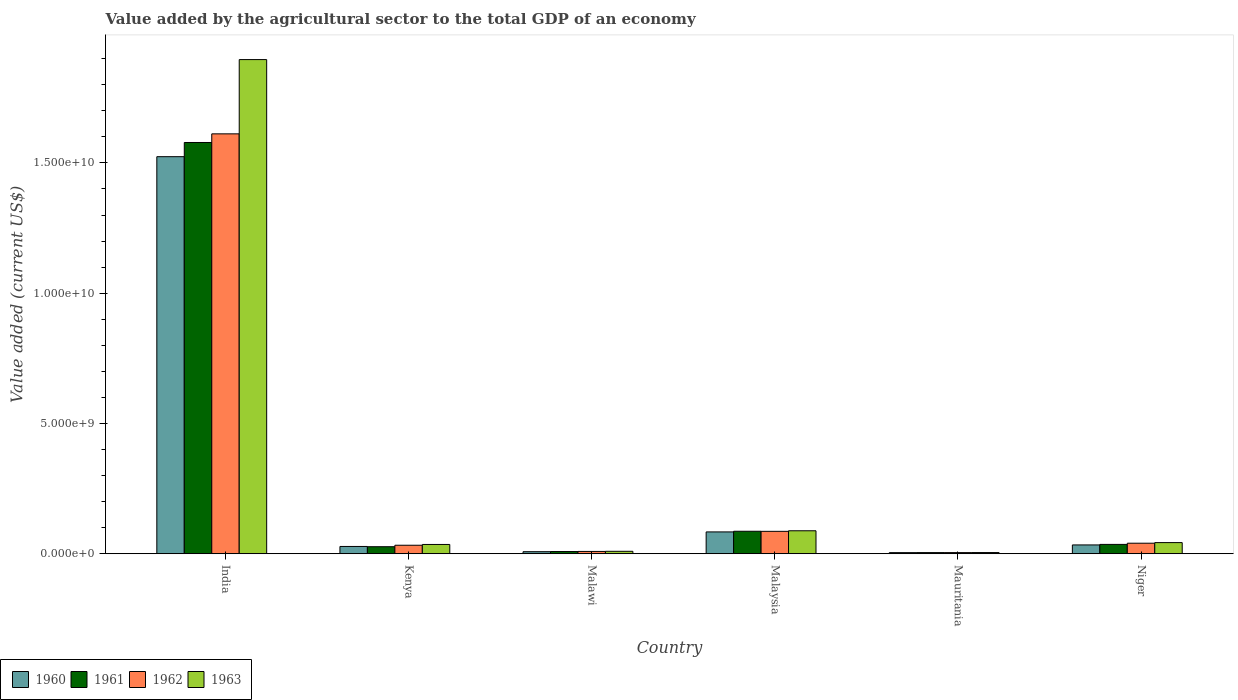Are the number of bars per tick equal to the number of legend labels?
Provide a short and direct response. Yes. How many bars are there on the 5th tick from the left?
Make the answer very short. 4. How many bars are there on the 1st tick from the right?
Make the answer very short. 4. What is the label of the 6th group of bars from the left?
Provide a short and direct response. Niger. In how many cases, is the number of bars for a given country not equal to the number of legend labels?
Provide a succinct answer. 0. What is the value added by the agricultural sector to the total GDP in 1963 in India?
Your answer should be very brief. 1.90e+1. Across all countries, what is the maximum value added by the agricultural sector to the total GDP in 1961?
Your response must be concise. 1.58e+1. Across all countries, what is the minimum value added by the agricultural sector to the total GDP in 1963?
Provide a short and direct response. 4.57e+07. In which country was the value added by the agricultural sector to the total GDP in 1961 minimum?
Keep it short and to the point. Mauritania. What is the total value added by the agricultural sector to the total GDP in 1961 in the graph?
Make the answer very short. 1.74e+1. What is the difference between the value added by the agricultural sector to the total GDP in 1962 in Malawi and that in Malaysia?
Offer a very short reply. -7.71e+08. What is the difference between the value added by the agricultural sector to the total GDP in 1963 in Malawi and the value added by the agricultural sector to the total GDP in 1960 in Malaysia?
Keep it short and to the point. -7.44e+08. What is the average value added by the agricultural sector to the total GDP in 1962 per country?
Your answer should be very brief. 2.97e+09. What is the difference between the value added by the agricultural sector to the total GDP of/in 1960 and value added by the agricultural sector to the total GDP of/in 1962 in Niger?
Provide a short and direct response. -6.55e+07. In how many countries, is the value added by the agricultural sector to the total GDP in 1963 greater than 8000000000 US$?
Offer a terse response. 1. What is the ratio of the value added by the agricultural sector to the total GDP in 1961 in Malaysia to that in Mauritania?
Make the answer very short. 19.73. Is the difference between the value added by the agricultural sector to the total GDP in 1960 in Kenya and Mauritania greater than the difference between the value added by the agricultural sector to the total GDP in 1962 in Kenya and Mauritania?
Provide a succinct answer. No. What is the difference between the highest and the second highest value added by the agricultural sector to the total GDP in 1961?
Your response must be concise. 1.49e+1. What is the difference between the highest and the lowest value added by the agricultural sector to the total GDP in 1962?
Keep it short and to the point. 1.61e+1. Is the sum of the value added by the agricultural sector to the total GDP in 1962 in Kenya and Mauritania greater than the maximum value added by the agricultural sector to the total GDP in 1961 across all countries?
Keep it short and to the point. No. What does the 1st bar from the left in Malawi represents?
Offer a terse response. 1960. Is it the case that in every country, the sum of the value added by the agricultural sector to the total GDP in 1960 and value added by the agricultural sector to the total GDP in 1963 is greater than the value added by the agricultural sector to the total GDP in 1962?
Ensure brevity in your answer.  Yes. How many bars are there?
Offer a terse response. 24. Are all the bars in the graph horizontal?
Make the answer very short. No. Does the graph contain any zero values?
Provide a succinct answer. No. Does the graph contain grids?
Offer a very short reply. No. Where does the legend appear in the graph?
Make the answer very short. Bottom left. How many legend labels are there?
Provide a short and direct response. 4. How are the legend labels stacked?
Your answer should be compact. Horizontal. What is the title of the graph?
Keep it short and to the point. Value added by the agricultural sector to the total GDP of an economy. What is the label or title of the X-axis?
Make the answer very short. Country. What is the label or title of the Y-axis?
Keep it short and to the point. Value added (current US$). What is the Value added (current US$) in 1960 in India?
Your answer should be compact. 1.52e+1. What is the Value added (current US$) in 1961 in India?
Offer a very short reply. 1.58e+1. What is the Value added (current US$) in 1962 in India?
Make the answer very short. 1.61e+1. What is the Value added (current US$) in 1963 in India?
Your response must be concise. 1.90e+1. What is the Value added (current US$) of 1960 in Kenya?
Provide a succinct answer. 2.80e+08. What is the Value added (current US$) of 1961 in Kenya?
Your answer should be compact. 2.70e+08. What is the Value added (current US$) in 1962 in Kenya?
Provide a succinct answer. 3.26e+08. What is the Value added (current US$) of 1963 in Kenya?
Ensure brevity in your answer.  3.56e+08. What is the Value added (current US$) in 1960 in Malawi?
Give a very brief answer. 7.88e+07. What is the Value added (current US$) in 1961 in Malawi?
Keep it short and to the point. 8.48e+07. What is the Value added (current US$) in 1962 in Malawi?
Your response must be concise. 8.90e+07. What is the Value added (current US$) of 1963 in Malawi?
Provide a short and direct response. 9.39e+07. What is the Value added (current US$) in 1960 in Malaysia?
Offer a very short reply. 8.38e+08. What is the Value added (current US$) in 1961 in Malaysia?
Offer a very short reply. 8.63e+08. What is the Value added (current US$) of 1962 in Malaysia?
Provide a succinct answer. 8.60e+08. What is the Value added (current US$) in 1963 in Malaysia?
Make the answer very short. 8.82e+08. What is the Value added (current US$) of 1960 in Mauritania?
Keep it short and to the point. 4.26e+07. What is the Value added (current US$) in 1961 in Mauritania?
Your response must be concise. 4.37e+07. What is the Value added (current US$) in 1962 in Mauritania?
Give a very brief answer. 4.41e+07. What is the Value added (current US$) in 1963 in Mauritania?
Give a very brief answer. 4.57e+07. What is the Value added (current US$) in 1960 in Niger?
Give a very brief answer. 3.39e+08. What is the Value added (current US$) in 1961 in Niger?
Your response must be concise. 3.59e+08. What is the Value added (current US$) of 1962 in Niger?
Ensure brevity in your answer.  4.04e+08. What is the Value added (current US$) of 1963 in Niger?
Give a very brief answer. 4.28e+08. Across all countries, what is the maximum Value added (current US$) of 1960?
Offer a very short reply. 1.52e+1. Across all countries, what is the maximum Value added (current US$) of 1961?
Keep it short and to the point. 1.58e+1. Across all countries, what is the maximum Value added (current US$) in 1962?
Keep it short and to the point. 1.61e+1. Across all countries, what is the maximum Value added (current US$) in 1963?
Make the answer very short. 1.90e+1. Across all countries, what is the minimum Value added (current US$) in 1960?
Offer a very short reply. 4.26e+07. Across all countries, what is the minimum Value added (current US$) in 1961?
Provide a succinct answer. 4.37e+07. Across all countries, what is the minimum Value added (current US$) in 1962?
Keep it short and to the point. 4.41e+07. Across all countries, what is the minimum Value added (current US$) in 1963?
Ensure brevity in your answer.  4.57e+07. What is the total Value added (current US$) in 1960 in the graph?
Your answer should be compact. 1.68e+1. What is the total Value added (current US$) in 1961 in the graph?
Give a very brief answer. 1.74e+1. What is the total Value added (current US$) in 1962 in the graph?
Give a very brief answer. 1.78e+1. What is the total Value added (current US$) in 1963 in the graph?
Offer a very short reply. 2.08e+1. What is the difference between the Value added (current US$) of 1960 in India and that in Kenya?
Your answer should be very brief. 1.50e+1. What is the difference between the Value added (current US$) in 1961 in India and that in Kenya?
Keep it short and to the point. 1.55e+1. What is the difference between the Value added (current US$) in 1962 in India and that in Kenya?
Provide a succinct answer. 1.58e+1. What is the difference between the Value added (current US$) of 1963 in India and that in Kenya?
Ensure brevity in your answer.  1.86e+1. What is the difference between the Value added (current US$) of 1960 in India and that in Malawi?
Keep it short and to the point. 1.52e+1. What is the difference between the Value added (current US$) in 1961 in India and that in Malawi?
Your answer should be very brief. 1.57e+1. What is the difference between the Value added (current US$) of 1962 in India and that in Malawi?
Keep it short and to the point. 1.60e+1. What is the difference between the Value added (current US$) in 1963 in India and that in Malawi?
Provide a short and direct response. 1.89e+1. What is the difference between the Value added (current US$) in 1960 in India and that in Malaysia?
Make the answer very short. 1.44e+1. What is the difference between the Value added (current US$) of 1961 in India and that in Malaysia?
Your response must be concise. 1.49e+1. What is the difference between the Value added (current US$) of 1962 in India and that in Malaysia?
Offer a very short reply. 1.53e+1. What is the difference between the Value added (current US$) of 1963 in India and that in Malaysia?
Offer a terse response. 1.81e+1. What is the difference between the Value added (current US$) in 1960 in India and that in Mauritania?
Ensure brevity in your answer.  1.52e+1. What is the difference between the Value added (current US$) of 1961 in India and that in Mauritania?
Provide a succinct answer. 1.57e+1. What is the difference between the Value added (current US$) of 1962 in India and that in Mauritania?
Give a very brief answer. 1.61e+1. What is the difference between the Value added (current US$) of 1963 in India and that in Mauritania?
Give a very brief answer. 1.89e+1. What is the difference between the Value added (current US$) of 1960 in India and that in Niger?
Provide a succinct answer. 1.49e+1. What is the difference between the Value added (current US$) in 1961 in India and that in Niger?
Your answer should be very brief. 1.54e+1. What is the difference between the Value added (current US$) in 1962 in India and that in Niger?
Your response must be concise. 1.57e+1. What is the difference between the Value added (current US$) of 1963 in India and that in Niger?
Your answer should be compact. 1.85e+1. What is the difference between the Value added (current US$) in 1960 in Kenya and that in Malawi?
Offer a very short reply. 2.01e+08. What is the difference between the Value added (current US$) in 1961 in Kenya and that in Malawi?
Keep it short and to the point. 1.85e+08. What is the difference between the Value added (current US$) of 1962 in Kenya and that in Malawi?
Your response must be concise. 2.37e+08. What is the difference between the Value added (current US$) in 1963 in Kenya and that in Malawi?
Provide a short and direct response. 2.62e+08. What is the difference between the Value added (current US$) of 1960 in Kenya and that in Malaysia?
Your answer should be compact. -5.58e+08. What is the difference between the Value added (current US$) of 1961 in Kenya and that in Malaysia?
Your answer should be very brief. -5.93e+08. What is the difference between the Value added (current US$) of 1962 in Kenya and that in Malaysia?
Give a very brief answer. -5.34e+08. What is the difference between the Value added (current US$) in 1963 in Kenya and that in Malaysia?
Keep it short and to the point. -5.25e+08. What is the difference between the Value added (current US$) of 1960 in Kenya and that in Mauritania?
Your response must be concise. 2.37e+08. What is the difference between the Value added (current US$) of 1961 in Kenya and that in Mauritania?
Offer a very short reply. 2.26e+08. What is the difference between the Value added (current US$) in 1962 in Kenya and that in Mauritania?
Provide a succinct answer. 2.82e+08. What is the difference between the Value added (current US$) in 1963 in Kenya and that in Mauritania?
Offer a very short reply. 3.11e+08. What is the difference between the Value added (current US$) of 1960 in Kenya and that in Niger?
Give a very brief answer. -5.89e+07. What is the difference between the Value added (current US$) in 1961 in Kenya and that in Niger?
Offer a very short reply. -8.87e+07. What is the difference between the Value added (current US$) of 1962 in Kenya and that in Niger?
Your answer should be compact. -7.79e+07. What is the difference between the Value added (current US$) in 1963 in Kenya and that in Niger?
Make the answer very short. -7.14e+07. What is the difference between the Value added (current US$) of 1960 in Malawi and that in Malaysia?
Offer a terse response. -7.59e+08. What is the difference between the Value added (current US$) of 1961 in Malawi and that in Malaysia?
Keep it short and to the point. -7.78e+08. What is the difference between the Value added (current US$) of 1962 in Malawi and that in Malaysia?
Give a very brief answer. -7.71e+08. What is the difference between the Value added (current US$) of 1963 in Malawi and that in Malaysia?
Provide a short and direct response. -7.88e+08. What is the difference between the Value added (current US$) of 1960 in Malawi and that in Mauritania?
Provide a short and direct response. 3.62e+07. What is the difference between the Value added (current US$) of 1961 in Malawi and that in Mauritania?
Make the answer very short. 4.11e+07. What is the difference between the Value added (current US$) of 1962 in Malawi and that in Mauritania?
Give a very brief answer. 4.49e+07. What is the difference between the Value added (current US$) in 1963 in Malawi and that in Mauritania?
Provide a short and direct response. 4.83e+07. What is the difference between the Value added (current US$) of 1960 in Malawi and that in Niger?
Your answer should be compact. -2.60e+08. What is the difference between the Value added (current US$) in 1961 in Malawi and that in Niger?
Keep it short and to the point. -2.74e+08. What is the difference between the Value added (current US$) of 1962 in Malawi and that in Niger?
Provide a short and direct response. -3.15e+08. What is the difference between the Value added (current US$) of 1963 in Malawi and that in Niger?
Give a very brief answer. -3.34e+08. What is the difference between the Value added (current US$) in 1960 in Malaysia and that in Mauritania?
Ensure brevity in your answer.  7.95e+08. What is the difference between the Value added (current US$) of 1961 in Malaysia and that in Mauritania?
Provide a succinct answer. 8.19e+08. What is the difference between the Value added (current US$) of 1962 in Malaysia and that in Mauritania?
Make the answer very short. 8.16e+08. What is the difference between the Value added (current US$) in 1963 in Malaysia and that in Mauritania?
Your response must be concise. 8.36e+08. What is the difference between the Value added (current US$) of 1960 in Malaysia and that in Niger?
Provide a short and direct response. 4.99e+08. What is the difference between the Value added (current US$) of 1961 in Malaysia and that in Niger?
Give a very brief answer. 5.04e+08. What is the difference between the Value added (current US$) in 1962 in Malaysia and that in Niger?
Offer a very short reply. 4.56e+08. What is the difference between the Value added (current US$) of 1963 in Malaysia and that in Niger?
Provide a short and direct response. 4.54e+08. What is the difference between the Value added (current US$) of 1960 in Mauritania and that in Niger?
Your answer should be very brief. -2.96e+08. What is the difference between the Value added (current US$) of 1961 in Mauritania and that in Niger?
Offer a terse response. -3.15e+08. What is the difference between the Value added (current US$) of 1962 in Mauritania and that in Niger?
Your response must be concise. -3.60e+08. What is the difference between the Value added (current US$) in 1963 in Mauritania and that in Niger?
Offer a very short reply. -3.82e+08. What is the difference between the Value added (current US$) of 1960 in India and the Value added (current US$) of 1961 in Kenya?
Your answer should be very brief. 1.50e+1. What is the difference between the Value added (current US$) in 1960 in India and the Value added (current US$) in 1962 in Kenya?
Make the answer very short. 1.49e+1. What is the difference between the Value added (current US$) of 1960 in India and the Value added (current US$) of 1963 in Kenya?
Your answer should be very brief. 1.49e+1. What is the difference between the Value added (current US$) of 1961 in India and the Value added (current US$) of 1962 in Kenya?
Make the answer very short. 1.55e+1. What is the difference between the Value added (current US$) in 1961 in India and the Value added (current US$) in 1963 in Kenya?
Ensure brevity in your answer.  1.54e+1. What is the difference between the Value added (current US$) in 1962 in India and the Value added (current US$) in 1963 in Kenya?
Your response must be concise. 1.58e+1. What is the difference between the Value added (current US$) of 1960 in India and the Value added (current US$) of 1961 in Malawi?
Ensure brevity in your answer.  1.52e+1. What is the difference between the Value added (current US$) in 1960 in India and the Value added (current US$) in 1962 in Malawi?
Keep it short and to the point. 1.51e+1. What is the difference between the Value added (current US$) of 1960 in India and the Value added (current US$) of 1963 in Malawi?
Your response must be concise. 1.51e+1. What is the difference between the Value added (current US$) of 1961 in India and the Value added (current US$) of 1962 in Malawi?
Provide a short and direct response. 1.57e+1. What is the difference between the Value added (current US$) in 1961 in India and the Value added (current US$) in 1963 in Malawi?
Provide a short and direct response. 1.57e+1. What is the difference between the Value added (current US$) of 1962 in India and the Value added (current US$) of 1963 in Malawi?
Keep it short and to the point. 1.60e+1. What is the difference between the Value added (current US$) of 1960 in India and the Value added (current US$) of 1961 in Malaysia?
Provide a short and direct response. 1.44e+1. What is the difference between the Value added (current US$) in 1960 in India and the Value added (current US$) in 1962 in Malaysia?
Your answer should be compact. 1.44e+1. What is the difference between the Value added (current US$) of 1960 in India and the Value added (current US$) of 1963 in Malaysia?
Give a very brief answer. 1.44e+1. What is the difference between the Value added (current US$) in 1961 in India and the Value added (current US$) in 1962 in Malaysia?
Offer a very short reply. 1.49e+1. What is the difference between the Value added (current US$) of 1961 in India and the Value added (current US$) of 1963 in Malaysia?
Give a very brief answer. 1.49e+1. What is the difference between the Value added (current US$) in 1962 in India and the Value added (current US$) in 1963 in Malaysia?
Your response must be concise. 1.52e+1. What is the difference between the Value added (current US$) of 1960 in India and the Value added (current US$) of 1961 in Mauritania?
Make the answer very short. 1.52e+1. What is the difference between the Value added (current US$) of 1960 in India and the Value added (current US$) of 1962 in Mauritania?
Make the answer very short. 1.52e+1. What is the difference between the Value added (current US$) in 1960 in India and the Value added (current US$) in 1963 in Mauritania?
Provide a short and direct response. 1.52e+1. What is the difference between the Value added (current US$) in 1961 in India and the Value added (current US$) in 1962 in Mauritania?
Your answer should be very brief. 1.57e+1. What is the difference between the Value added (current US$) of 1961 in India and the Value added (current US$) of 1963 in Mauritania?
Offer a very short reply. 1.57e+1. What is the difference between the Value added (current US$) of 1962 in India and the Value added (current US$) of 1963 in Mauritania?
Your answer should be compact. 1.61e+1. What is the difference between the Value added (current US$) of 1960 in India and the Value added (current US$) of 1961 in Niger?
Provide a succinct answer. 1.49e+1. What is the difference between the Value added (current US$) in 1960 in India and the Value added (current US$) in 1962 in Niger?
Your response must be concise. 1.48e+1. What is the difference between the Value added (current US$) in 1960 in India and the Value added (current US$) in 1963 in Niger?
Make the answer very short. 1.48e+1. What is the difference between the Value added (current US$) in 1961 in India and the Value added (current US$) in 1962 in Niger?
Make the answer very short. 1.54e+1. What is the difference between the Value added (current US$) in 1961 in India and the Value added (current US$) in 1963 in Niger?
Offer a very short reply. 1.54e+1. What is the difference between the Value added (current US$) of 1962 in India and the Value added (current US$) of 1963 in Niger?
Make the answer very short. 1.57e+1. What is the difference between the Value added (current US$) of 1960 in Kenya and the Value added (current US$) of 1961 in Malawi?
Keep it short and to the point. 1.95e+08. What is the difference between the Value added (current US$) in 1960 in Kenya and the Value added (current US$) in 1962 in Malawi?
Your answer should be compact. 1.91e+08. What is the difference between the Value added (current US$) in 1960 in Kenya and the Value added (current US$) in 1963 in Malawi?
Provide a succinct answer. 1.86e+08. What is the difference between the Value added (current US$) in 1961 in Kenya and the Value added (current US$) in 1962 in Malawi?
Make the answer very short. 1.81e+08. What is the difference between the Value added (current US$) in 1961 in Kenya and the Value added (current US$) in 1963 in Malawi?
Offer a very short reply. 1.76e+08. What is the difference between the Value added (current US$) of 1962 in Kenya and the Value added (current US$) of 1963 in Malawi?
Give a very brief answer. 2.32e+08. What is the difference between the Value added (current US$) in 1960 in Kenya and the Value added (current US$) in 1961 in Malaysia?
Your answer should be compact. -5.83e+08. What is the difference between the Value added (current US$) in 1960 in Kenya and the Value added (current US$) in 1962 in Malaysia?
Your answer should be compact. -5.80e+08. What is the difference between the Value added (current US$) in 1960 in Kenya and the Value added (current US$) in 1963 in Malaysia?
Your answer should be very brief. -6.02e+08. What is the difference between the Value added (current US$) of 1961 in Kenya and the Value added (current US$) of 1962 in Malaysia?
Make the answer very short. -5.90e+08. What is the difference between the Value added (current US$) of 1961 in Kenya and the Value added (current US$) of 1963 in Malaysia?
Give a very brief answer. -6.11e+08. What is the difference between the Value added (current US$) in 1962 in Kenya and the Value added (current US$) in 1963 in Malaysia?
Keep it short and to the point. -5.55e+08. What is the difference between the Value added (current US$) of 1960 in Kenya and the Value added (current US$) of 1961 in Mauritania?
Ensure brevity in your answer.  2.36e+08. What is the difference between the Value added (current US$) in 1960 in Kenya and the Value added (current US$) in 1962 in Mauritania?
Ensure brevity in your answer.  2.36e+08. What is the difference between the Value added (current US$) in 1960 in Kenya and the Value added (current US$) in 1963 in Mauritania?
Provide a succinct answer. 2.34e+08. What is the difference between the Value added (current US$) of 1961 in Kenya and the Value added (current US$) of 1962 in Mauritania?
Make the answer very short. 2.26e+08. What is the difference between the Value added (current US$) in 1961 in Kenya and the Value added (current US$) in 1963 in Mauritania?
Make the answer very short. 2.25e+08. What is the difference between the Value added (current US$) of 1962 in Kenya and the Value added (current US$) of 1963 in Mauritania?
Your answer should be compact. 2.81e+08. What is the difference between the Value added (current US$) in 1960 in Kenya and the Value added (current US$) in 1961 in Niger?
Provide a short and direct response. -7.92e+07. What is the difference between the Value added (current US$) of 1960 in Kenya and the Value added (current US$) of 1962 in Niger?
Offer a very short reply. -1.24e+08. What is the difference between the Value added (current US$) of 1960 in Kenya and the Value added (current US$) of 1963 in Niger?
Offer a very short reply. -1.48e+08. What is the difference between the Value added (current US$) of 1961 in Kenya and the Value added (current US$) of 1962 in Niger?
Offer a terse response. -1.34e+08. What is the difference between the Value added (current US$) of 1961 in Kenya and the Value added (current US$) of 1963 in Niger?
Provide a succinct answer. -1.58e+08. What is the difference between the Value added (current US$) in 1962 in Kenya and the Value added (current US$) in 1963 in Niger?
Your answer should be compact. -1.02e+08. What is the difference between the Value added (current US$) of 1960 in Malawi and the Value added (current US$) of 1961 in Malaysia?
Your answer should be very brief. -7.84e+08. What is the difference between the Value added (current US$) in 1960 in Malawi and the Value added (current US$) in 1962 in Malaysia?
Give a very brief answer. -7.81e+08. What is the difference between the Value added (current US$) of 1960 in Malawi and the Value added (current US$) of 1963 in Malaysia?
Your answer should be compact. -8.03e+08. What is the difference between the Value added (current US$) of 1961 in Malawi and the Value added (current US$) of 1962 in Malaysia?
Offer a very short reply. -7.75e+08. What is the difference between the Value added (current US$) of 1961 in Malawi and the Value added (current US$) of 1963 in Malaysia?
Ensure brevity in your answer.  -7.97e+08. What is the difference between the Value added (current US$) of 1962 in Malawi and the Value added (current US$) of 1963 in Malaysia?
Your answer should be very brief. -7.93e+08. What is the difference between the Value added (current US$) in 1960 in Malawi and the Value added (current US$) in 1961 in Mauritania?
Your response must be concise. 3.51e+07. What is the difference between the Value added (current US$) of 1960 in Malawi and the Value added (current US$) of 1962 in Mauritania?
Keep it short and to the point. 3.47e+07. What is the difference between the Value added (current US$) in 1960 in Malawi and the Value added (current US$) in 1963 in Mauritania?
Give a very brief answer. 3.32e+07. What is the difference between the Value added (current US$) in 1961 in Malawi and the Value added (current US$) in 1962 in Mauritania?
Your answer should be compact. 4.07e+07. What is the difference between the Value added (current US$) of 1961 in Malawi and the Value added (current US$) of 1963 in Mauritania?
Make the answer very short. 3.92e+07. What is the difference between the Value added (current US$) in 1962 in Malawi and the Value added (current US$) in 1963 in Mauritania?
Your response must be concise. 4.34e+07. What is the difference between the Value added (current US$) of 1960 in Malawi and the Value added (current US$) of 1961 in Niger?
Make the answer very short. -2.80e+08. What is the difference between the Value added (current US$) in 1960 in Malawi and the Value added (current US$) in 1962 in Niger?
Ensure brevity in your answer.  -3.25e+08. What is the difference between the Value added (current US$) in 1960 in Malawi and the Value added (current US$) in 1963 in Niger?
Offer a terse response. -3.49e+08. What is the difference between the Value added (current US$) of 1961 in Malawi and the Value added (current US$) of 1962 in Niger?
Give a very brief answer. -3.19e+08. What is the difference between the Value added (current US$) in 1961 in Malawi and the Value added (current US$) in 1963 in Niger?
Offer a terse response. -3.43e+08. What is the difference between the Value added (current US$) in 1962 in Malawi and the Value added (current US$) in 1963 in Niger?
Your response must be concise. -3.39e+08. What is the difference between the Value added (current US$) of 1960 in Malaysia and the Value added (current US$) of 1961 in Mauritania?
Provide a succinct answer. 7.94e+08. What is the difference between the Value added (current US$) in 1960 in Malaysia and the Value added (current US$) in 1962 in Mauritania?
Your answer should be compact. 7.94e+08. What is the difference between the Value added (current US$) of 1960 in Malaysia and the Value added (current US$) of 1963 in Mauritania?
Your response must be concise. 7.92e+08. What is the difference between the Value added (current US$) in 1961 in Malaysia and the Value added (current US$) in 1962 in Mauritania?
Provide a succinct answer. 8.19e+08. What is the difference between the Value added (current US$) in 1961 in Malaysia and the Value added (current US$) in 1963 in Mauritania?
Offer a very short reply. 8.17e+08. What is the difference between the Value added (current US$) of 1962 in Malaysia and the Value added (current US$) of 1963 in Mauritania?
Offer a terse response. 8.14e+08. What is the difference between the Value added (current US$) in 1960 in Malaysia and the Value added (current US$) in 1961 in Niger?
Give a very brief answer. 4.79e+08. What is the difference between the Value added (current US$) in 1960 in Malaysia and the Value added (current US$) in 1962 in Niger?
Make the answer very short. 4.34e+08. What is the difference between the Value added (current US$) in 1960 in Malaysia and the Value added (current US$) in 1963 in Niger?
Your answer should be compact. 4.10e+08. What is the difference between the Value added (current US$) in 1961 in Malaysia and the Value added (current US$) in 1962 in Niger?
Your response must be concise. 4.59e+08. What is the difference between the Value added (current US$) of 1961 in Malaysia and the Value added (current US$) of 1963 in Niger?
Keep it short and to the point. 4.35e+08. What is the difference between the Value added (current US$) of 1962 in Malaysia and the Value added (current US$) of 1963 in Niger?
Provide a succinct answer. 4.32e+08. What is the difference between the Value added (current US$) of 1960 in Mauritania and the Value added (current US$) of 1961 in Niger?
Offer a terse response. -3.16e+08. What is the difference between the Value added (current US$) of 1960 in Mauritania and the Value added (current US$) of 1962 in Niger?
Your answer should be very brief. -3.62e+08. What is the difference between the Value added (current US$) in 1960 in Mauritania and the Value added (current US$) in 1963 in Niger?
Your response must be concise. -3.85e+08. What is the difference between the Value added (current US$) of 1961 in Mauritania and the Value added (current US$) of 1962 in Niger?
Ensure brevity in your answer.  -3.60e+08. What is the difference between the Value added (current US$) of 1961 in Mauritania and the Value added (current US$) of 1963 in Niger?
Keep it short and to the point. -3.84e+08. What is the difference between the Value added (current US$) of 1962 in Mauritania and the Value added (current US$) of 1963 in Niger?
Ensure brevity in your answer.  -3.84e+08. What is the average Value added (current US$) in 1960 per country?
Offer a terse response. 2.80e+09. What is the average Value added (current US$) in 1961 per country?
Your answer should be very brief. 2.90e+09. What is the average Value added (current US$) of 1962 per country?
Offer a terse response. 2.97e+09. What is the average Value added (current US$) of 1963 per country?
Ensure brevity in your answer.  3.46e+09. What is the difference between the Value added (current US$) of 1960 and Value added (current US$) of 1961 in India?
Your answer should be compact. -5.45e+08. What is the difference between the Value added (current US$) in 1960 and Value added (current US$) in 1962 in India?
Your response must be concise. -8.76e+08. What is the difference between the Value added (current US$) of 1960 and Value added (current US$) of 1963 in India?
Your response must be concise. -3.73e+09. What is the difference between the Value added (current US$) of 1961 and Value added (current US$) of 1962 in India?
Give a very brief answer. -3.32e+08. What is the difference between the Value added (current US$) of 1961 and Value added (current US$) of 1963 in India?
Give a very brief answer. -3.18e+09. What is the difference between the Value added (current US$) of 1962 and Value added (current US$) of 1963 in India?
Give a very brief answer. -2.85e+09. What is the difference between the Value added (current US$) in 1960 and Value added (current US$) in 1961 in Kenya?
Your response must be concise. 9.51e+06. What is the difference between the Value added (current US$) in 1960 and Value added (current US$) in 1962 in Kenya?
Keep it short and to the point. -4.65e+07. What is the difference between the Value added (current US$) in 1960 and Value added (current US$) in 1963 in Kenya?
Provide a short and direct response. -7.66e+07. What is the difference between the Value added (current US$) of 1961 and Value added (current US$) of 1962 in Kenya?
Your answer should be compact. -5.60e+07. What is the difference between the Value added (current US$) in 1961 and Value added (current US$) in 1963 in Kenya?
Offer a terse response. -8.61e+07. What is the difference between the Value added (current US$) of 1962 and Value added (current US$) of 1963 in Kenya?
Offer a terse response. -3.01e+07. What is the difference between the Value added (current US$) of 1960 and Value added (current US$) of 1961 in Malawi?
Offer a terse response. -6.02e+06. What is the difference between the Value added (current US$) of 1960 and Value added (current US$) of 1962 in Malawi?
Ensure brevity in your answer.  -1.02e+07. What is the difference between the Value added (current US$) of 1960 and Value added (current US$) of 1963 in Malawi?
Your response must be concise. -1.51e+07. What is the difference between the Value added (current US$) of 1961 and Value added (current US$) of 1962 in Malawi?
Ensure brevity in your answer.  -4.20e+06. What is the difference between the Value added (current US$) in 1961 and Value added (current US$) in 1963 in Malawi?
Provide a succinct answer. -9.10e+06. What is the difference between the Value added (current US$) in 1962 and Value added (current US$) in 1963 in Malawi?
Your answer should be compact. -4.90e+06. What is the difference between the Value added (current US$) in 1960 and Value added (current US$) in 1961 in Malaysia?
Make the answer very short. -2.54e+07. What is the difference between the Value added (current US$) of 1960 and Value added (current US$) of 1962 in Malaysia?
Give a very brief answer. -2.23e+07. What is the difference between the Value added (current US$) in 1960 and Value added (current US$) in 1963 in Malaysia?
Ensure brevity in your answer.  -4.39e+07. What is the difference between the Value added (current US$) in 1961 and Value added (current US$) in 1962 in Malaysia?
Offer a terse response. 3.09e+06. What is the difference between the Value added (current US$) of 1961 and Value added (current US$) of 1963 in Malaysia?
Ensure brevity in your answer.  -1.85e+07. What is the difference between the Value added (current US$) of 1962 and Value added (current US$) of 1963 in Malaysia?
Offer a very short reply. -2.16e+07. What is the difference between the Value added (current US$) in 1960 and Value added (current US$) in 1961 in Mauritania?
Provide a succinct answer. -1.15e+06. What is the difference between the Value added (current US$) of 1960 and Value added (current US$) of 1962 in Mauritania?
Your response must be concise. -1.54e+06. What is the difference between the Value added (current US$) in 1960 and Value added (current US$) in 1963 in Mauritania?
Offer a very short reply. -3.07e+06. What is the difference between the Value added (current US$) in 1961 and Value added (current US$) in 1962 in Mauritania?
Offer a terse response. -3.84e+05. What is the difference between the Value added (current US$) in 1961 and Value added (current US$) in 1963 in Mauritania?
Keep it short and to the point. -1.92e+06. What is the difference between the Value added (current US$) of 1962 and Value added (current US$) of 1963 in Mauritania?
Give a very brief answer. -1.54e+06. What is the difference between the Value added (current US$) in 1960 and Value added (current US$) in 1961 in Niger?
Provide a short and direct response. -2.03e+07. What is the difference between the Value added (current US$) in 1960 and Value added (current US$) in 1962 in Niger?
Keep it short and to the point. -6.55e+07. What is the difference between the Value added (current US$) in 1960 and Value added (current US$) in 1963 in Niger?
Your answer should be very brief. -8.91e+07. What is the difference between the Value added (current US$) in 1961 and Value added (current US$) in 1962 in Niger?
Make the answer very short. -4.52e+07. What is the difference between the Value added (current US$) of 1961 and Value added (current US$) of 1963 in Niger?
Provide a short and direct response. -6.88e+07. What is the difference between the Value added (current US$) in 1962 and Value added (current US$) in 1963 in Niger?
Provide a short and direct response. -2.36e+07. What is the ratio of the Value added (current US$) in 1960 in India to that in Kenya?
Offer a very short reply. 54.48. What is the ratio of the Value added (current US$) in 1961 in India to that in Kenya?
Provide a succinct answer. 58.42. What is the ratio of the Value added (current US$) of 1962 in India to that in Kenya?
Give a very brief answer. 49.4. What is the ratio of the Value added (current US$) of 1963 in India to that in Kenya?
Offer a terse response. 53.23. What is the ratio of the Value added (current US$) in 1960 in India to that in Malawi?
Your response must be concise. 193.33. What is the ratio of the Value added (current US$) of 1961 in India to that in Malawi?
Make the answer very short. 186.04. What is the ratio of the Value added (current US$) of 1962 in India to that in Malawi?
Ensure brevity in your answer.  180.99. What is the ratio of the Value added (current US$) of 1963 in India to that in Malawi?
Keep it short and to the point. 201.89. What is the ratio of the Value added (current US$) in 1960 in India to that in Malaysia?
Your answer should be very brief. 18.19. What is the ratio of the Value added (current US$) in 1961 in India to that in Malaysia?
Keep it short and to the point. 18.29. What is the ratio of the Value added (current US$) of 1962 in India to that in Malaysia?
Make the answer very short. 18.74. What is the ratio of the Value added (current US$) of 1963 in India to that in Malaysia?
Make the answer very short. 21.51. What is the ratio of the Value added (current US$) in 1960 in India to that in Mauritania?
Provide a short and direct response. 357.73. What is the ratio of the Value added (current US$) of 1961 in India to that in Mauritania?
Your response must be concise. 360.77. What is the ratio of the Value added (current US$) of 1962 in India to that in Mauritania?
Offer a very short reply. 365.15. What is the ratio of the Value added (current US$) of 1963 in India to that in Mauritania?
Keep it short and to the point. 415.29. What is the ratio of the Value added (current US$) of 1960 in India to that in Niger?
Provide a succinct answer. 45. What is the ratio of the Value added (current US$) of 1961 in India to that in Niger?
Provide a short and direct response. 43.97. What is the ratio of the Value added (current US$) of 1962 in India to that in Niger?
Your answer should be very brief. 39.88. What is the ratio of the Value added (current US$) in 1963 in India to that in Niger?
Your response must be concise. 44.34. What is the ratio of the Value added (current US$) of 1960 in Kenya to that in Malawi?
Provide a short and direct response. 3.55. What is the ratio of the Value added (current US$) in 1961 in Kenya to that in Malawi?
Your response must be concise. 3.18. What is the ratio of the Value added (current US$) of 1962 in Kenya to that in Malawi?
Give a very brief answer. 3.66. What is the ratio of the Value added (current US$) in 1963 in Kenya to that in Malawi?
Provide a succinct answer. 3.79. What is the ratio of the Value added (current US$) in 1960 in Kenya to that in Malaysia?
Your answer should be very brief. 0.33. What is the ratio of the Value added (current US$) in 1961 in Kenya to that in Malaysia?
Your answer should be very brief. 0.31. What is the ratio of the Value added (current US$) in 1962 in Kenya to that in Malaysia?
Your answer should be compact. 0.38. What is the ratio of the Value added (current US$) in 1963 in Kenya to that in Malaysia?
Make the answer very short. 0.4. What is the ratio of the Value added (current US$) in 1960 in Kenya to that in Mauritania?
Your response must be concise. 6.57. What is the ratio of the Value added (current US$) in 1961 in Kenya to that in Mauritania?
Keep it short and to the point. 6.18. What is the ratio of the Value added (current US$) in 1962 in Kenya to that in Mauritania?
Your answer should be compact. 7.39. What is the ratio of the Value added (current US$) of 1963 in Kenya to that in Mauritania?
Your answer should be very brief. 7.8. What is the ratio of the Value added (current US$) of 1960 in Kenya to that in Niger?
Make the answer very short. 0.83. What is the ratio of the Value added (current US$) in 1961 in Kenya to that in Niger?
Your answer should be very brief. 0.75. What is the ratio of the Value added (current US$) of 1962 in Kenya to that in Niger?
Your answer should be very brief. 0.81. What is the ratio of the Value added (current US$) of 1963 in Kenya to that in Niger?
Offer a very short reply. 0.83. What is the ratio of the Value added (current US$) of 1960 in Malawi to that in Malaysia?
Give a very brief answer. 0.09. What is the ratio of the Value added (current US$) in 1961 in Malawi to that in Malaysia?
Provide a succinct answer. 0.1. What is the ratio of the Value added (current US$) of 1962 in Malawi to that in Malaysia?
Offer a very short reply. 0.1. What is the ratio of the Value added (current US$) in 1963 in Malawi to that in Malaysia?
Provide a succinct answer. 0.11. What is the ratio of the Value added (current US$) in 1960 in Malawi to that in Mauritania?
Provide a succinct answer. 1.85. What is the ratio of the Value added (current US$) in 1961 in Malawi to that in Mauritania?
Provide a short and direct response. 1.94. What is the ratio of the Value added (current US$) in 1962 in Malawi to that in Mauritania?
Give a very brief answer. 2.02. What is the ratio of the Value added (current US$) in 1963 in Malawi to that in Mauritania?
Ensure brevity in your answer.  2.06. What is the ratio of the Value added (current US$) of 1960 in Malawi to that in Niger?
Make the answer very short. 0.23. What is the ratio of the Value added (current US$) in 1961 in Malawi to that in Niger?
Offer a terse response. 0.24. What is the ratio of the Value added (current US$) in 1962 in Malawi to that in Niger?
Provide a succinct answer. 0.22. What is the ratio of the Value added (current US$) in 1963 in Malawi to that in Niger?
Provide a short and direct response. 0.22. What is the ratio of the Value added (current US$) of 1960 in Malaysia to that in Mauritania?
Your answer should be very brief. 19.67. What is the ratio of the Value added (current US$) in 1961 in Malaysia to that in Mauritania?
Give a very brief answer. 19.73. What is the ratio of the Value added (current US$) in 1962 in Malaysia to that in Mauritania?
Your answer should be very brief. 19.49. What is the ratio of the Value added (current US$) of 1963 in Malaysia to that in Mauritania?
Your answer should be very brief. 19.31. What is the ratio of the Value added (current US$) in 1960 in Malaysia to that in Niger?
Ensure brevity in your answer.  2.47. What is the ratio of the Value added (current US$) in 1961 in Malaysia to that in Niger?
Your response must be concise. 2.4. What is the ratio of the Value added (current US$) of 1962 in Malaysia to that in Niger?
Ensure brevity in your answer.  2.13. What is the ratio of the Value added (current US$) in 1963 in Malaysia to that in Niger?
Your answer should be compact. 2.06. What is the ratio of the Value added (current US$) of 1960 in Mauritania to that in Niger?
Provide a succinct answer. 0.13. What is the ratio of the Value added (current US$) of 1961 in Mauritania to that in Niger?
Provide a succinct answer. 0.12. What is the ratio of the Value added (current US$) in 1962 in Mauritania to that in Niger?
Make the answer very short. 0.11. What is the ratio of the Value added (current US$) in 1963 in Mauritania to that in Niger?
Offer a very short reply. 0.11. What is the difference between the highest and the second highest Value added (current US$) of 1960?
Provide a short and direct response. 1.44e+1. What is the difference between the highest and the second highest Value added (current US$) in 1961?
Your answer should be compact. 1.49e+1. What is the difference between the highest and the second highest Value added (current US$) of 1962?
Give a very brief answer. 1.53e+1. What is the difference between the highest and the second highest Value added (current US$) in 1963?
Offer a terse response. 1.81e+1. What is the difference between the highest and the lowest Value added (current US$) of 1960?
Give a very brief answer. 1.52e+1. What is the difference between the highest and the lowest Value added (current US$) of 1961?
Provide a short and direct response. 1.57e+1. What is the difference between the highest and the lowest Value added (current US$) in 1962?
Give a very brief answer. 1.61e+1. What is the difference between the highest and the lowest Value added (current US$) in 1963?
Your answer should be very brief. 1.89e+1. 